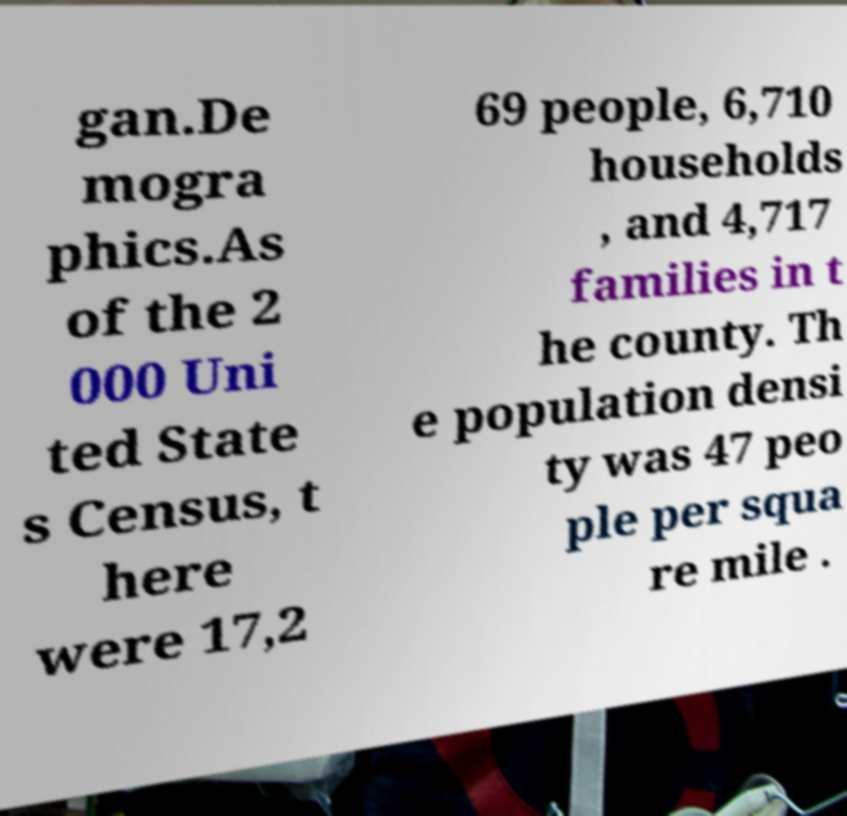Could you extract and type out the text from this image? gan.De mogra phics.As of the 2 000 Uni ted State s Census, t here were 17,2 69 people, 6,710 households , and 4,717 families in t he county. Th e population densi ty was 47 peo ple per squa re mile . 